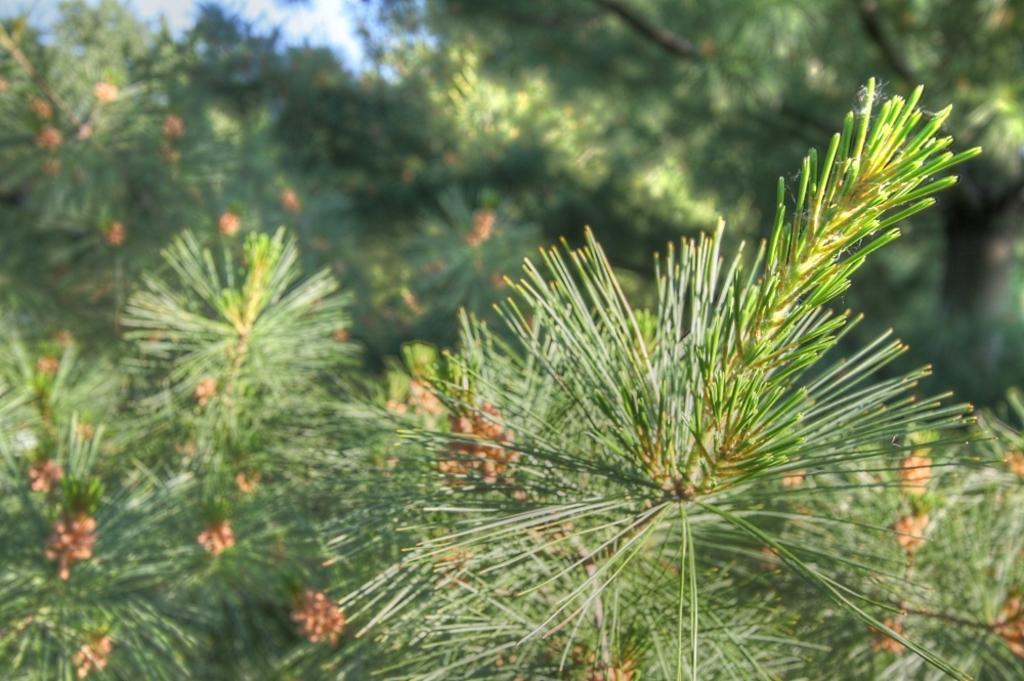Describe this image in one or two sentences. In this image, we can see few trees with some orange flowers. Background there is a blur view. 